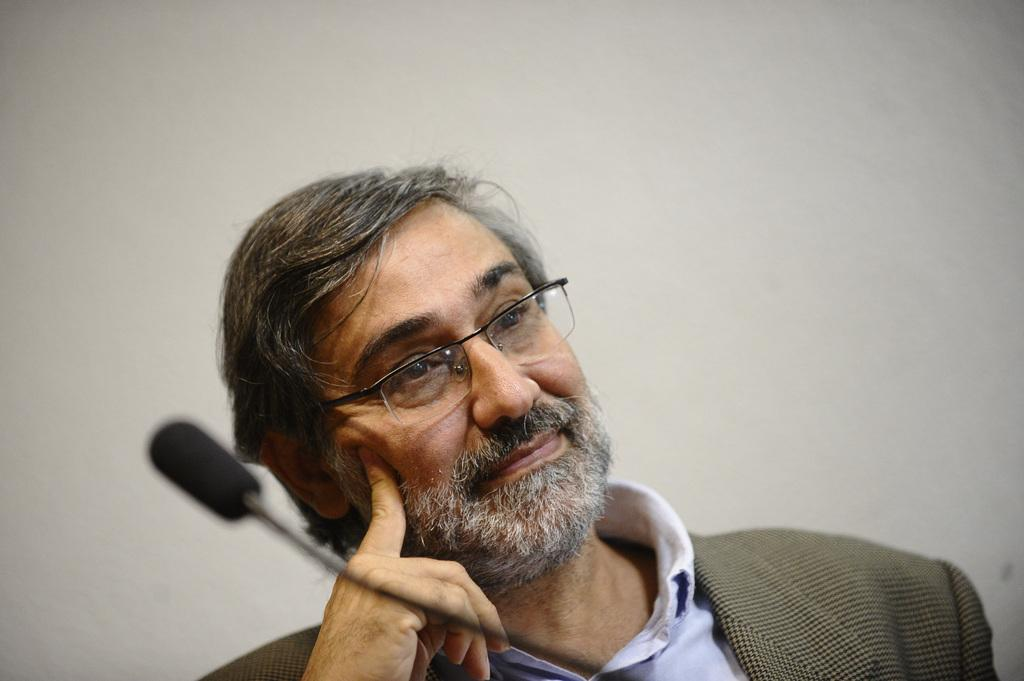Who or what is the main subject in the image? There is a person in the image. What is the person wearing? The person is wearing a brown color blazer. What object is in front of the person? There is a microphone in front of the person. What color is the wall in the background? The wall in the background is cream-colored. What type of bun is the person holding in the image? There is no bun present in the image. Is the person in jail in the image? There is no indication of a jail or any confinement in the image. 